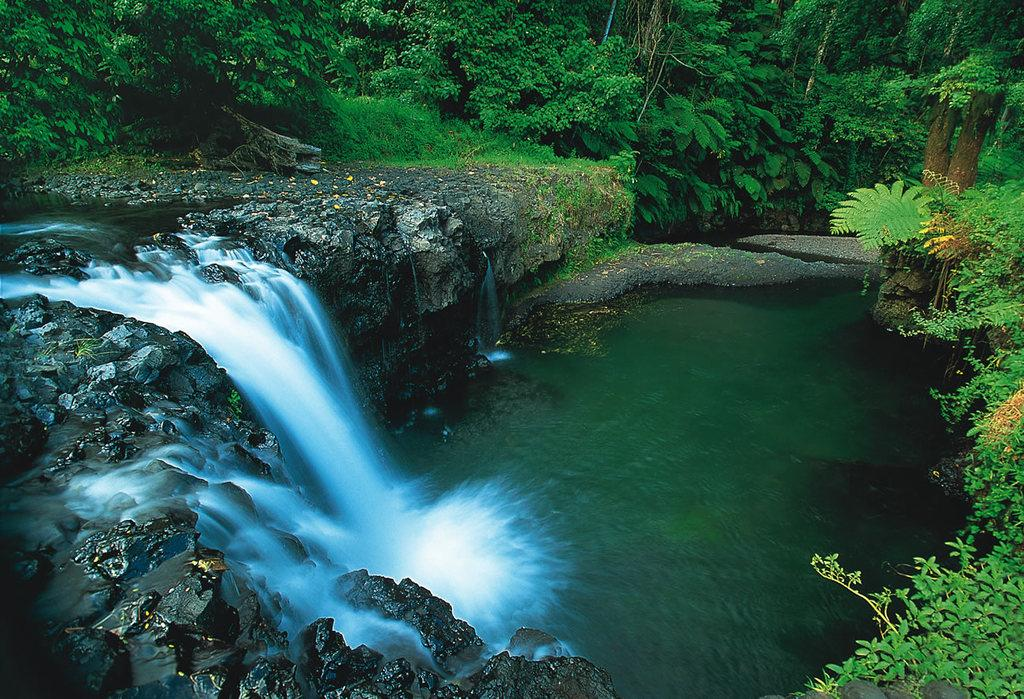What natural feature is located on the left side of the image? There is a waterfall on the left side of the image. What is present on the right side of the image? There is water on the right side of the image. What can be seen in the background of the image? There are trees in the background of the image. Are there any trees visible on the right side of the image? Yes, there are trees on the right side of the image. What type of copper material can be seen in the image? There is no copper material present in the image. How many trees are leaning on the slope in the image? There is no slope or leaning trees present in the image. 